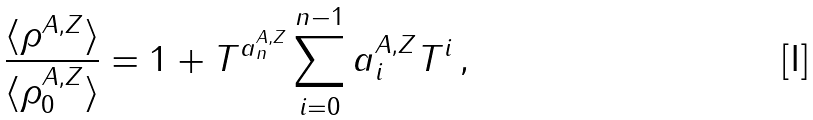<formula> <loc_0><loc_0><loc_500><loc_500>\frac { \langle \rho ^ { A , Z } \rangle } { \langle \rho _ { 0 } ^ { A , Z } \rangle } = 1 + T ^ { a _ { n } ^ { A , Z } } \sum _ { i = 0 } ^ { n - 1 } a _ { i } ^ { A , Z } T ^ { i } \, ,</formula> 